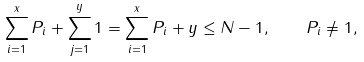<formula> <loc_0><loc_0><loc_500><loc_500>\sum _ { i = 1 } ^ { x } P _ { i } + \sum _ { j = 1 } ^ { y } 1 = \sum _ { i = 1 } ^ { x } P _ { i } + y \leq N - 1 , \quad P _ { i } \neq 1 ,</formula> 